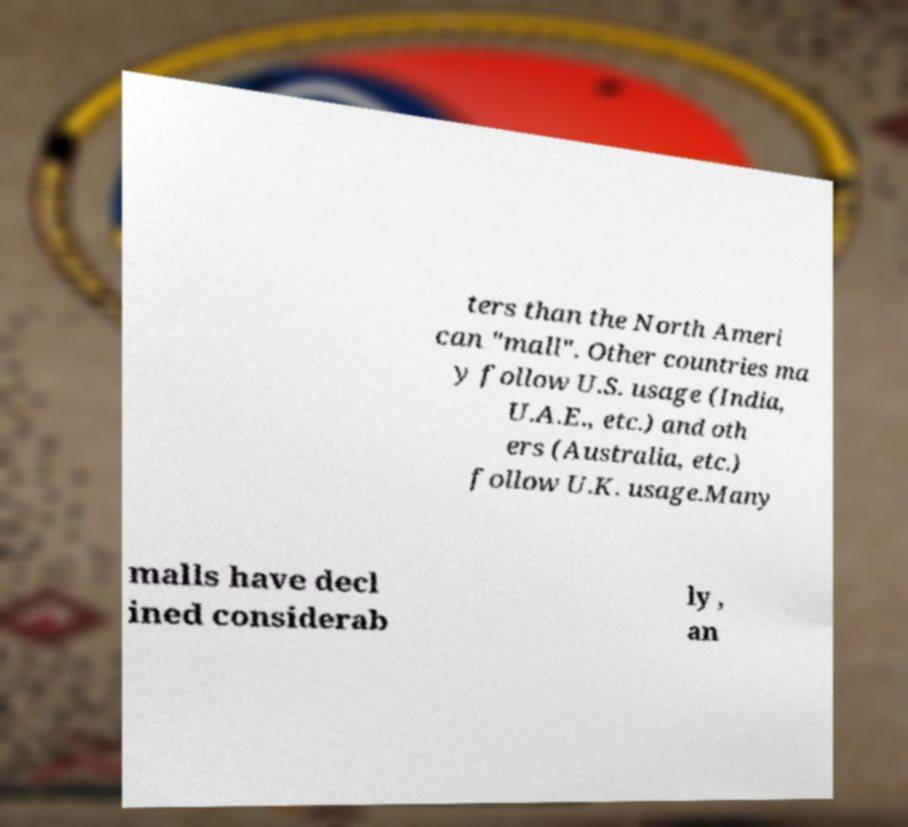Can you accurately transcribe the text from the provided image for me? ters than the North Ameri can "mall". Other countries ma y follow U.S. usage (India, U.A.E., etc.) and oth ers (Australia, etc.) follow U.K. usage.Many malls have decl ined considerab ly , an 